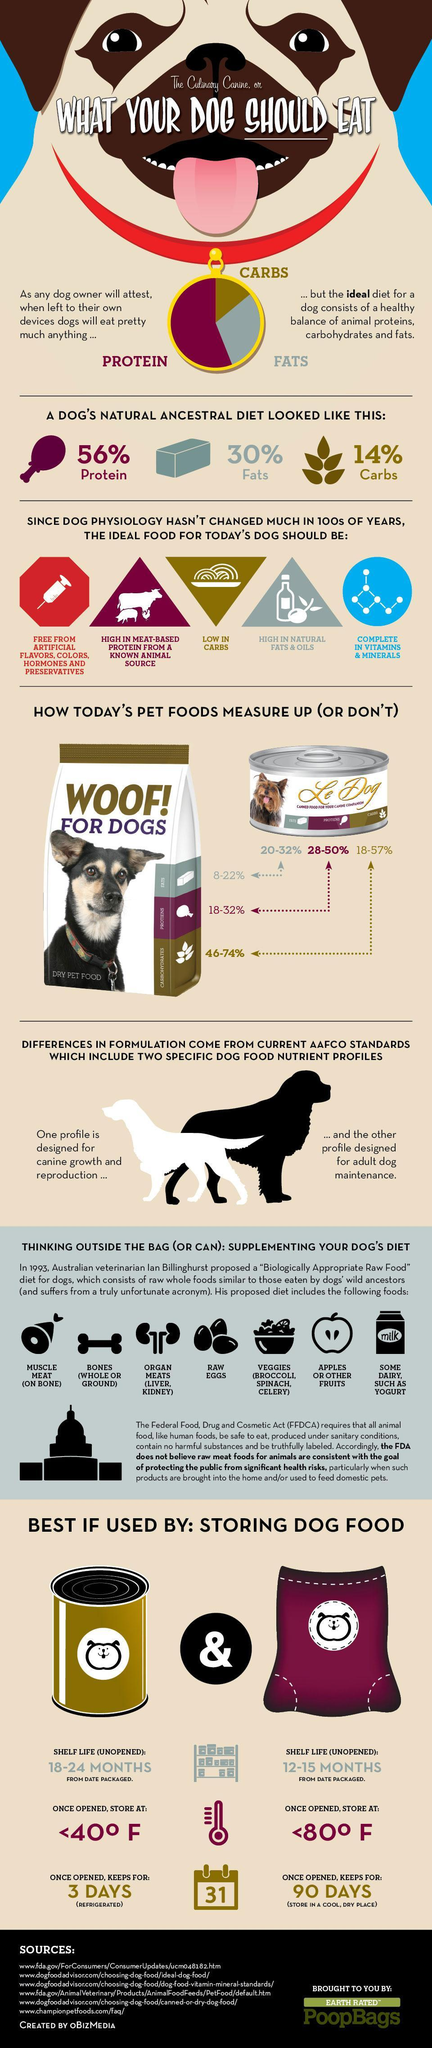Which are the two forms in which bones can be consumed by dogs?
Answer the question with a short phrase. Whole or ground How many different dog food formulations are available? 2 For how long can canned dog food be refrigerated after opening? 3 days How many 'biologically appropriate a raw food diet' for dogs are mentioned here? 7 Which is the last item mentioned under  "biologically appropriate raw food"  for dogs? Some diary, such as yoghurt What is the third feature mentioned under, 'the ideal food for today's dog'? Low in carbs What percentage of dry dog food comprises of of proteins? 18-32% How much fats did a dog's natural ancestral diet contain? 30% Which has a longer shelf life, canned dog food or dry dog food? Canned dog food What are the three "nutrients"  that an ideal diet for a dog must contain? Protein, fats, carbs What are each of the two specific dog food profiles designed for? Canine growth and reproduction, adult dog maintenance What is the shelf life for dry dog food? 12 - 15 months from date packaged What percentage of canned dog food comprises of proteins? 28-50% What was the percentage of carbs in the ancestral diet for dogs? 14% Once opened, which can be stored for longer time, canned dog food or dry dog food? Dry dog food What is the shelf life for canned dog food? 18 - 24 months from date packaged For how long can dry dog food be stored after opening it? 90 days Which type of dog food has a higher protein content, dry pet food or canned food? Canned food What should be the ideal dog food 'free from'? Artificial flavors, colors, hormones and preservatives Name the two organ meats that are considered to be appropriate for dog food? Liver, kidney Where can dry dog food be stored, once opened? a cool, dry place How many features of of the ideal food for today's dog are mentioned? 5 Which nutrient did the ancestral diet mainly consist of? Protein Which is the fourth item mentioned under the raw food diet for dogs? Raw eggs Name three veggies that can be considered as appropriate dog food? Broccoli, spinach, celery What type of protein should the "ideal dog food"  be rich in? Meat-based protein from a known animal source What is the percentage of fats in a dogs 'ancestral diet'? 30% 